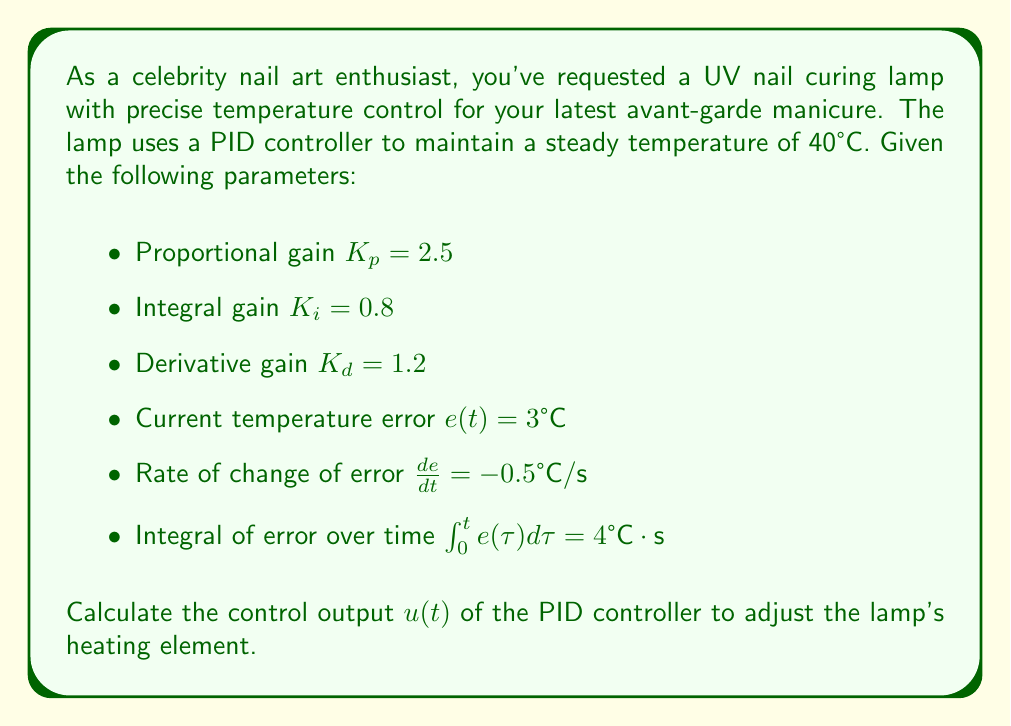Help me with this question. To solve this problem, we need to use the PID controller equation:

$$u(t) = K_p e(t) + K_i \int_0^t e(\tau)d\tau + K_d \frac{de}{dt}$$

Where:
- $u(t)$ is the control output
- $K_p$ is the proportional gain
- $K_i$ is the integral gain
- $K_d$ is the derivative gain
- $e(t)$ is the current error
- $\int_0^t e(\tau)d\tau$ is the integral of error over time
- $\frac{de}{dt}$ is the rate of change of error

Let's substitute the given values into the equation:

1. Proportional term: $K_p e(t) = 2.5 \cdot 3 = 7.5$

2. Integral term: $K_i \int_0^t e(\tau)d\tau = 0.8 \cdot 4 = 3.2$

3. Derivative term: $K_d \frac{de}{dt} = 1.2 \cdot (-0.5) = -0.6$

Now, we sum up all three terms:

$$u(t) = 7.5 + 3.2 + (-0.6) = 10.1$$

This value represents the control output that will be used to adjust the heating element of the UV nail curing lamp.
Answer: $u(t) = 10.1$ 